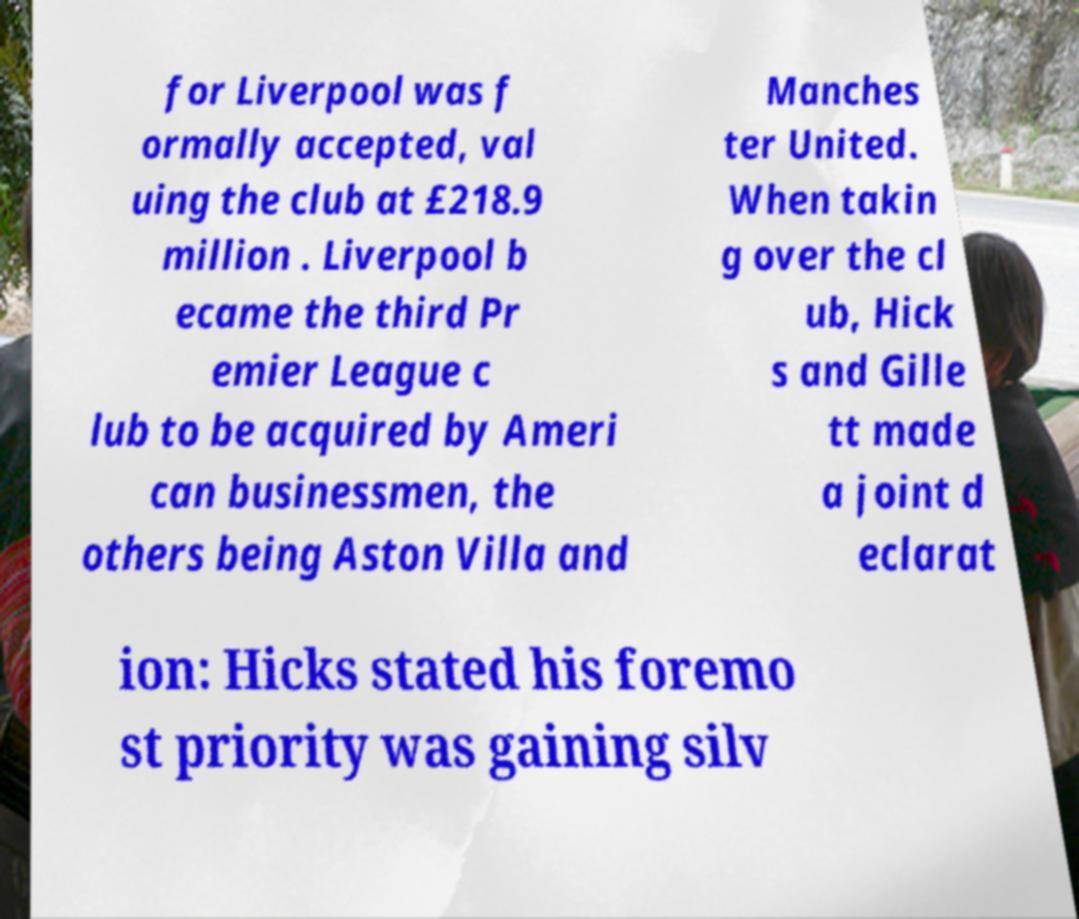Please read and relay the text visible in this image. What does it say? for Liverpool was f ormally accepted, val uing the club at £218.9 million . Liverpool b ecame the third Pr emier League c lub to be acquired by Ameri can businessmen, the others being Aston Villa and Manches ter United. When takin g over the cl ub, Hick s and Gille tt made a joint d eclarat ion: Hicks stated his foremo st priority was gaining silv 